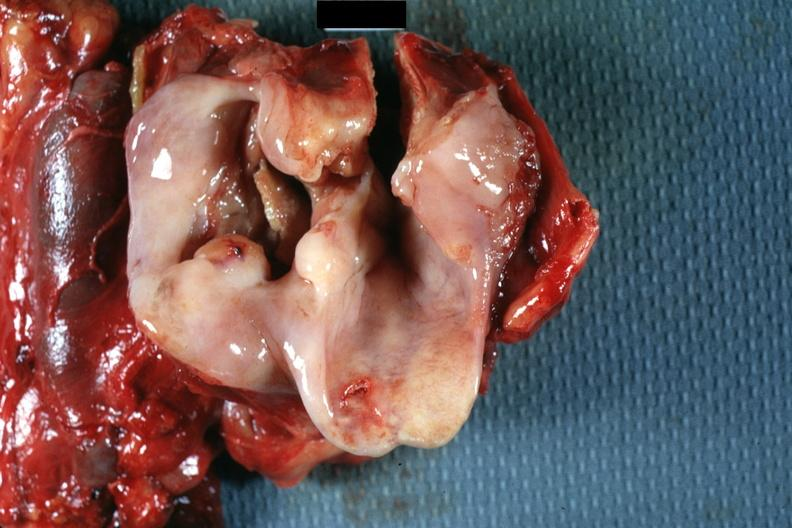what is present?
Answer the question using a single word or phrase. Hypopharynx 